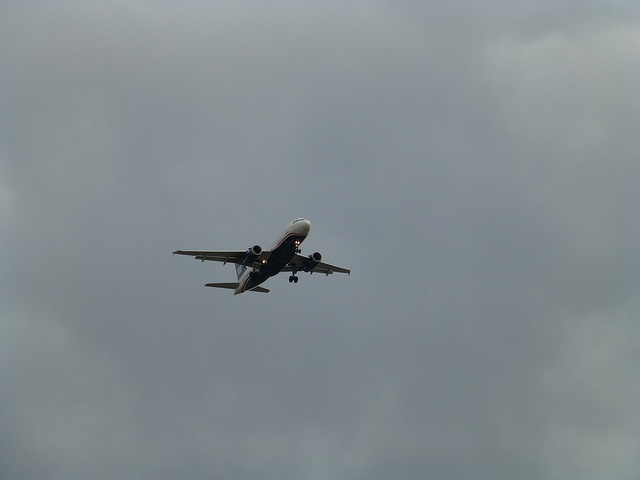Describe the objects in this image and their specific colors. I can see a airplane in darkgray, black, and gray tones in this image. 